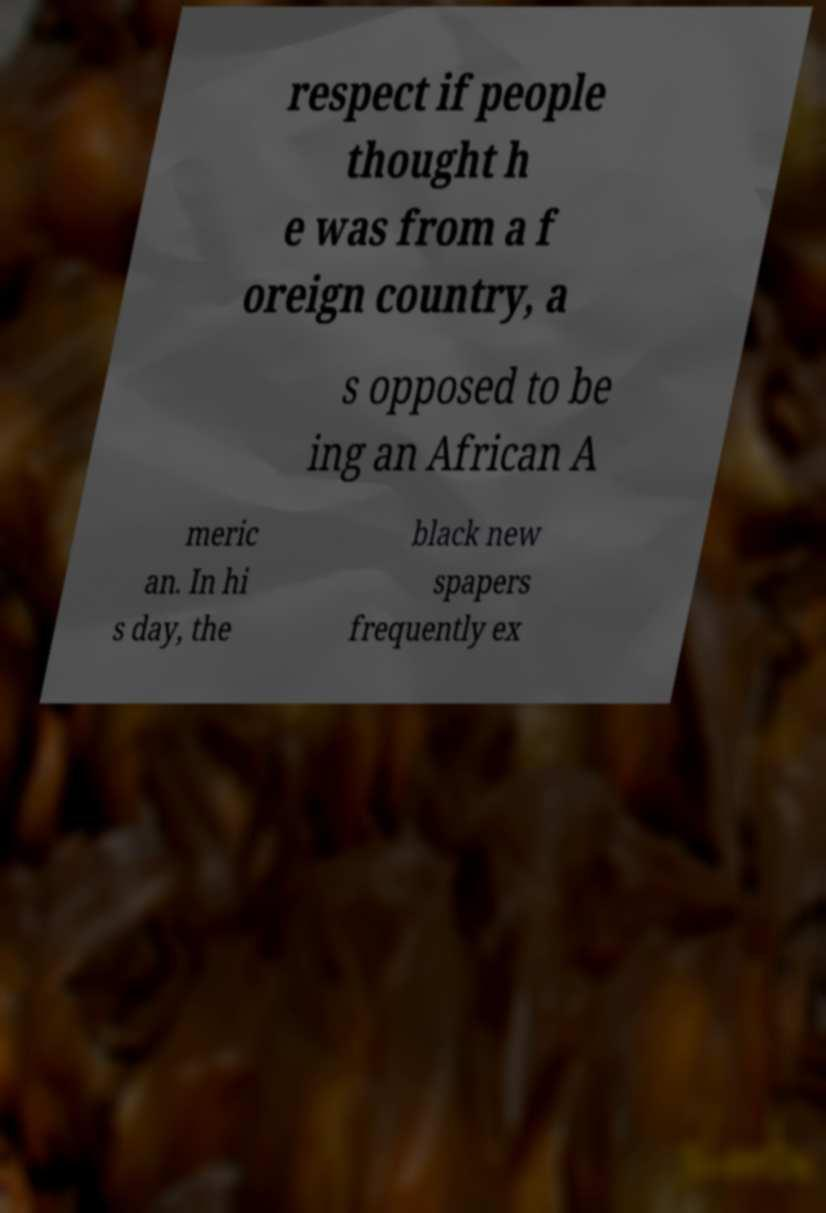Can you accurately transcribe the text from the provided image for me? respect if people thought h e was from a f oreign country, a s opposed to be ing an African A meric an. In hi s day, the black new spapers frequently ex 